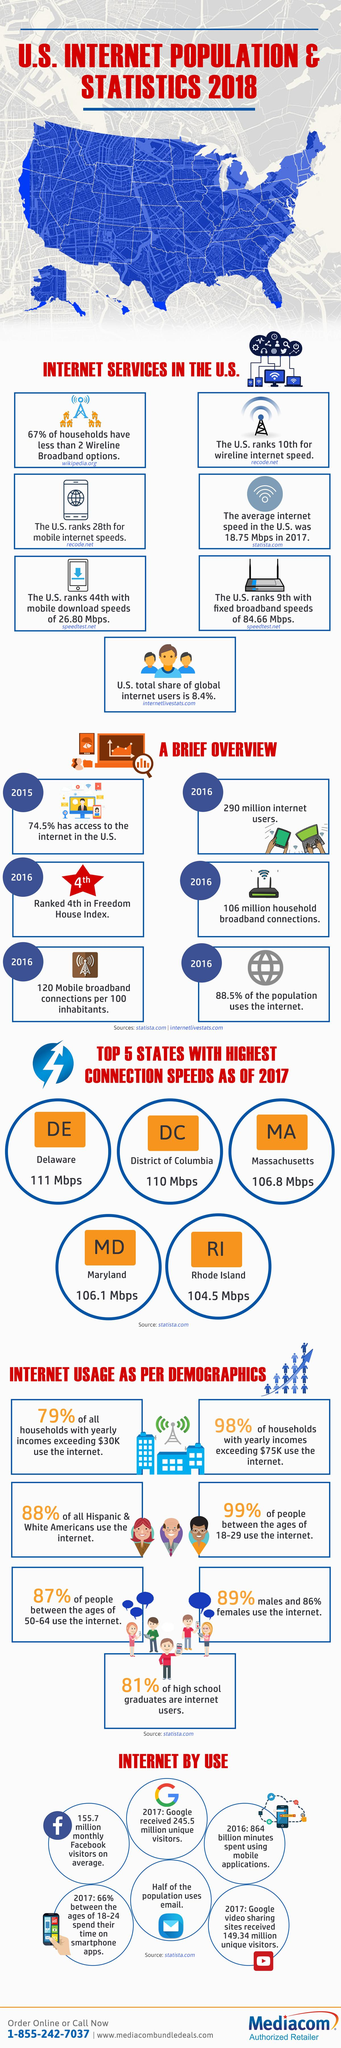Give some essential details in this illustration. As of 2017, the highest broadband connection speed available in the United States was 111 Mbps. The broadband internet connection speed in the District of Columbia was 110 Mbps as of 2017, which demonstrates the availability of high-speed internet access in the area. In 2015, approximately 25.5% of people in the United States did not have access to the internet. According to data from 2017, the District of Columbia has the second highest average connection speed among all states in the United States. The population of internet users in the United States in 2016 was estimated to be 290 million. 